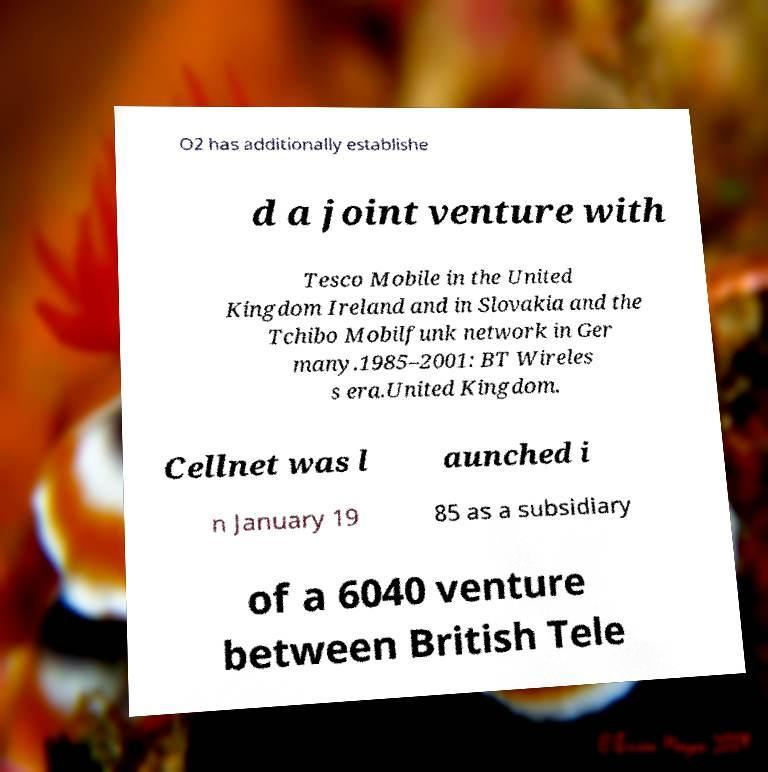Can you read and provide the text displayed in the image?This photo seems to have some interesting text. Can you extract and type it out for me? O2 has additionally establishe d a joint venture with Tesco Mobile in the United Kingdom Ireland and in Slovakia and the Tchibo Mobilfunk network in Ger many.1985–2001: BT Wireles s era.United Kingdom. Cellnet was l aunched i n January 19 85 as a subsidiary of a 6040 venture between British Tele 